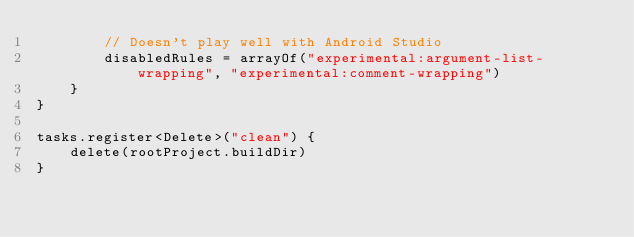<code> <loc_0><loc_0><loc_500><loc_500><_Kotlin_>        // Doesn't play well with Android Studio
        disabledRules = arrayOf("experimental:argument-list-wrapping", "experimental:comment-wrapping")
    }
}

tasks.register<Delete>("clean") {
    delete(rootProject.buildDir)
}
</code> 